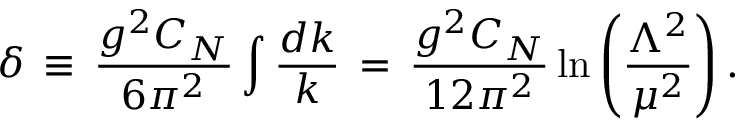Convert formula to latex. <formula><loc_0><loc_0><loc_500><loc_500>\delta \, \equiv \, \frac { g ^ { 2 } C _ { N } } { 6 \pi ^ { 2 } } \int \frac { d k } { k } \, = \, \frac { g ^ { 2 } C _ { N } } { 1 2 \pi ^ { 2 } } \ln \left ( \frac { \Lambda ^ { 2 } } { \mu ^ { 2 } } \right ) .</formula> 